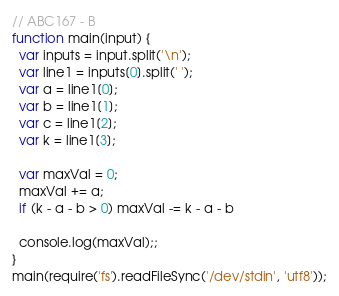<code> <loc_0><loc_0><loc_500><loc_500><_JavaScript_>// ABC167 - B
function main(input) {
  var inputs = input.split('\n');
  var line1 = inputs[0].split(' ');
  var a = line1[0];
  var b = line1[1];
  var c = line1[2];
  var k = line1[3];

  var maxVal = 0;
  maxVal += a;
  if (k - a - b > 0) maxVal -= k - a - b

  console.log(maxVal);;
}
main(require('fs').readFileSync('/dev/stdin', 'utf8'));
</code> 